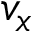Convert formula to latex. <formula><loc_0><loc_0><loc_500><loc_500>v _ { x }</formula> 